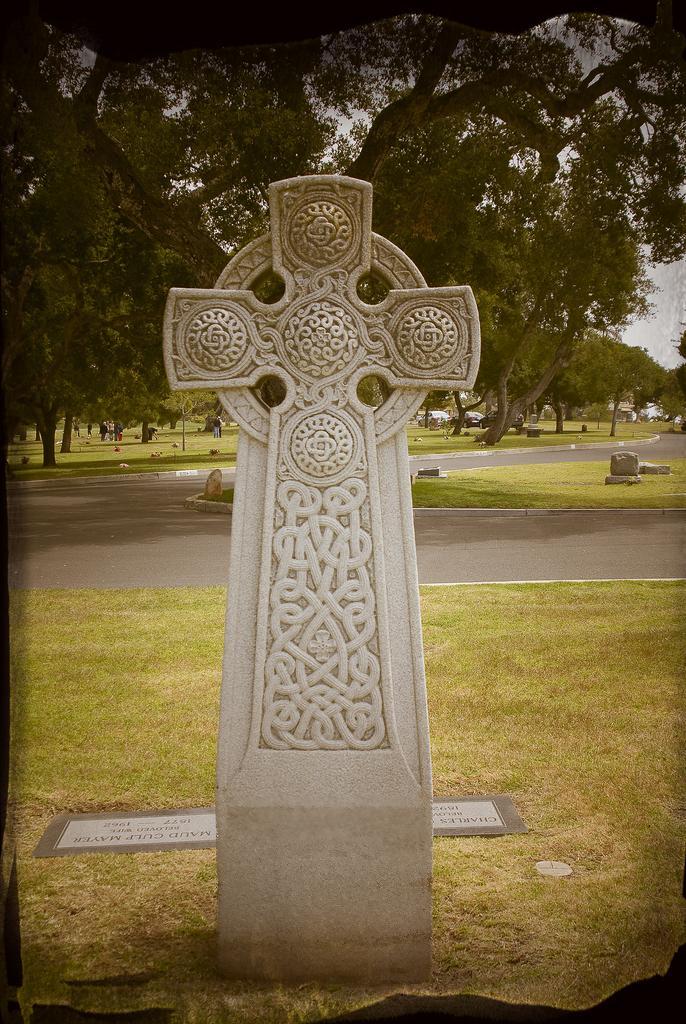In one or two sentences, can you explain what this image depicts? In the front of the image I can see a memorial stone. In the background of the image there is a board, grass, road, stones, trees and sky.   